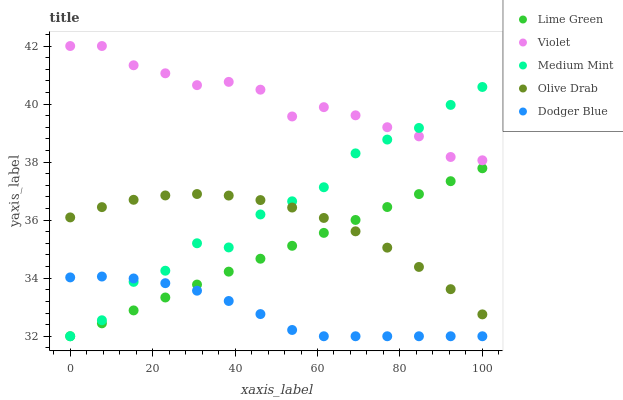Does Dodger Blue have the minimum area under the curve?
Answer yes or no. Yes. Does Violet have the maximum area under the curve?
Answer yes or no. Yes. Does Lime Green have the minimum area under the curve?
Answer yes or no. No. Does Lime Green have the maximum area under the curve?
Answer yes or no. No. Is Lime Green the smoothest?
Answer yes or no. Yes. Is Medium Mint the roughest?
Answer yes or no. Yes. Is Dodger Blue the smoothest?
Answer yes or no. No. Is Dodger Blue the roughest?
Answer yes or no. No. Does Medium Mint have the lowest value?
Answer yes or no. Yes. Does Olive Drab have the lowest value?
Answer yes or no. No. Does Violet have the highest value?
Answer yes or no. Yes. Does Lime Green have the highest value?
Answer yes or no. No. Is Dodger Blue less than Violet?
Answer yes or no. Yes. Is Violet greater than Lime Green?
Answer yes or no. Yes. Does Medium Mint intersect Lime Green?
Answer yes or no. Yes. Is Medium Mint less than Lime Green?
Answer yes or no. No. Is Medium Mint greater than Lime Green?
Answer yes or no. No. Does Dodger Blue intersect Violet?
Answer yes or no. No. 